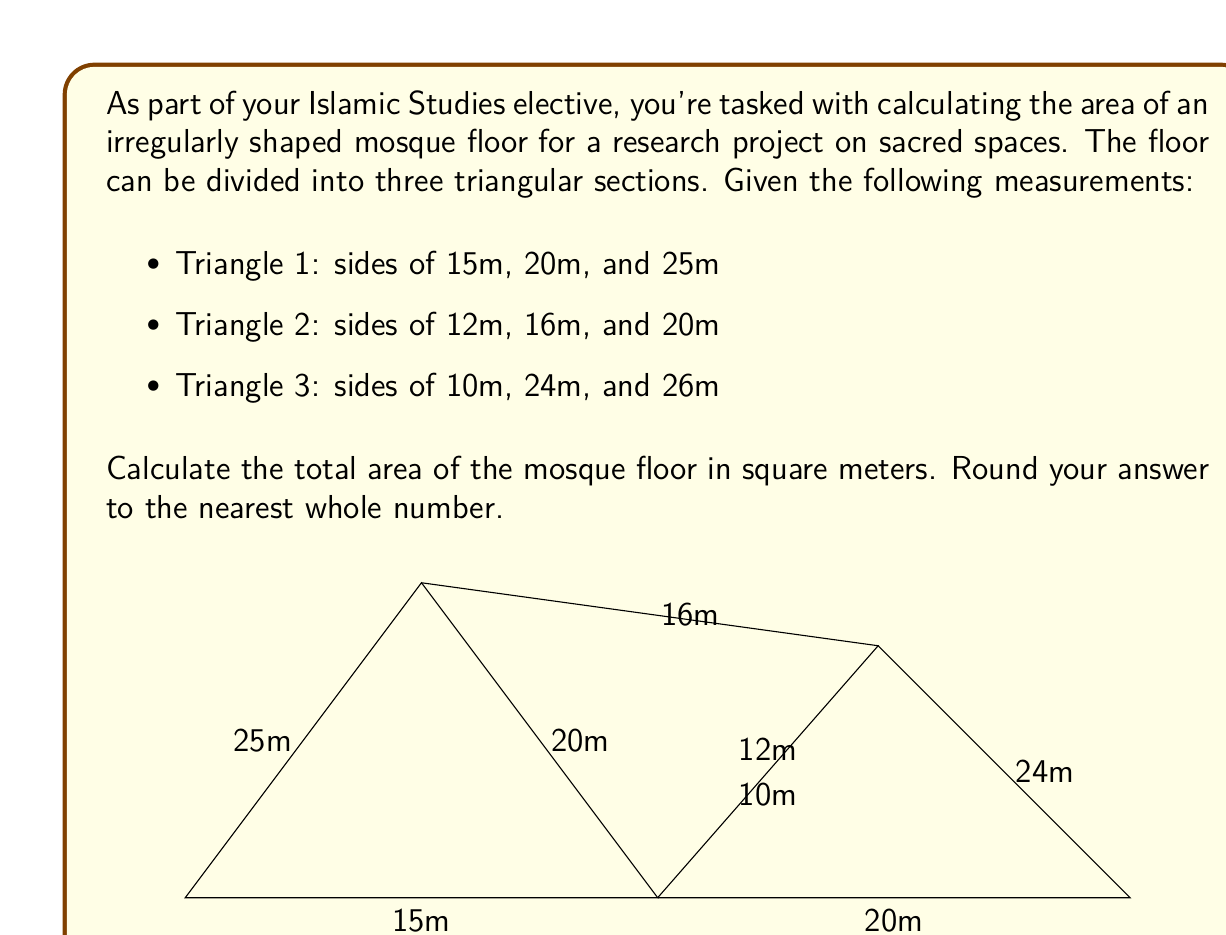Can you solve this math problem? To solve this problem, we'll use Heron's formula to calculate the area of each triangle and then sum them up. Heron's formula states that the area $A$ of a triangle with sides $a$, $b$, and $c$ is:

$$A = \sqrt{s(s-a)(s-b)(s-c)}$$

where $s$ is the semi-perimeter, calculated as:

$$s = \frac{a + b + c}{2}$$

Let's calculate the area of each triangle:

1. Triangle 1 (15m, 20m, 25m):
   $s_1 = \frac{15 + 20 + 25}{2} = 30$
   $A_1 = \sqrt{30(30-15)(30-20)(30-25)} = \sqrt{30 \cdot 15 \cdot 10 \cdot 5} = \sqrt{22500} = 150$ sq m

2. Triangle 2 (12m, 16m, 20m):
   $s_2 = \frac{12 + 16 + 20}{2} = 24$
   $A_2 = \sqrt{24(24-12)(24-16)(24-20)} = \sqrt{24 \cdot 12 \cdot 8 \cdot 4} = \sqrt{9216} = 96$ sq m

3. Triangle 3 (10m, 24m, 26m):
   $s_3 = \frac{10 + 24 + 26}{2} = 30$
   $A_3 = \sqrt{30(30-10)(30-24)(30-26)} = \sqrt{30 \cdot 20 \cdot 6 \cdot 4} = \sqrt{14400} = 120$ sq m

The total area is the sum of these three triangles:

$A_{total} = A_1 + A_2 + A_3 = 150 + 96 + 120 = 366$ sq m

Rounding to the nearest whole number, we get 366 sq m.
Answer: 366 sq m 